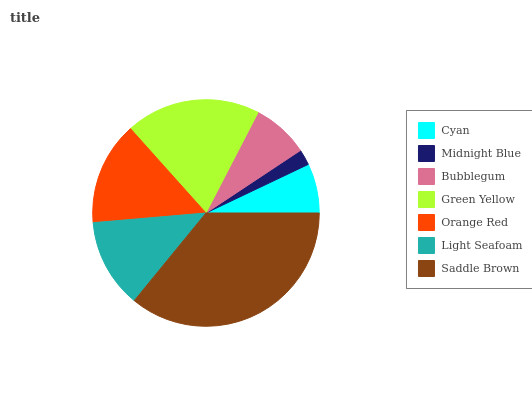Is Midnight Blue the minimum?
Answer yes or no. Yes. Is Saddle Brown the maximum?
Answer yes or no. Yes. Is Bubblegum the minimum?
Answer yes or no. No. Is Bubblegum the maximum?
Answer yes or no. No. Is Bubblegum greater than Midnight Blue?
Answer yes or no. Yes. Is Midnight Blue less than Bubblegum?
Answer yes or no. Yes. Is Midnight Blue greater than Bubblegum?
Answer yes or no. No. Is Bubblegum less than Midnight Blue?
Answer yes or no. No. Is Light Seafoam the high median?
Answer yes or no. Yes. Is Light Seafoam the low median?
Answer yes or no. Yes. Is Bubblegum the high median?
Answer yes or no. No. Is Green Yellow the low median?
Answer yes or no. No. 